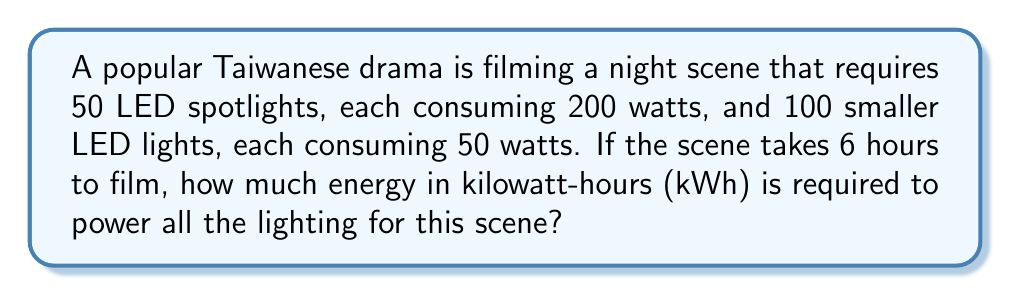Show me your answer to this math problem. Let's approach this step-by-step:

1) First, calculate the total power consumption of the spotlights:
   $$ P_{spotlights} = 50 \times 200 \text{ W} = 10,000 \text{ W} = 10 \text{ kW} $$

2) Next, calculate the total power consumption of the smaller lights:
   $$ P_{small lights} = 100 \times 50 \text{ W} = 5,000 \text{ W} = 5 \text{ kW} $$

3) Sum up the total power consumption:
   $$ P_{total} = P_{spotlights} + P_{small lights} = 10 \text{ kW} + 5 \text{ kW} = 15 \text{ kW} $$

4) Energy is power multiplied by time. The scene takes 6 hours to film:
   $$ E = P_{total} \times t = 15 \text{ kW} \times 6 \text{ h} = 90 \text{ kWh} $$

Therefore, the total energy required to power all the lighting for this scene is 90 kWh.
Answer: 90 kWh 